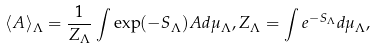Convert formula to latex. <formula><loc_0><loc_0><loc_500><loc_500>\langle A \rangle _ { \Lambda } = \frac { 1 } { Z _ { \Lambda } } \int \exp ( - S _ { \Lambda } ) A d \mu _ { \Lambda } , Z _ { \Lambda } = \int e ^ { - S _ { \Lambda } } d \mu _ { \Lambda } ,</formula> 